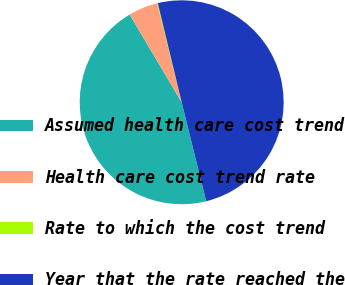Convert chart to OTSL. <chart><loc_0><loc_0><loc_500><loc_500><pie_chart><fcel>Assumed health care cost trend<fcel>Health care cost trend rate<fcel>Rate to which the cost trend<fcel>Year that the rate reached the<nl><fcel>45.35%<fcel>4.65%<fcel>0.11%<fcel>49.89%<nl></chart> 